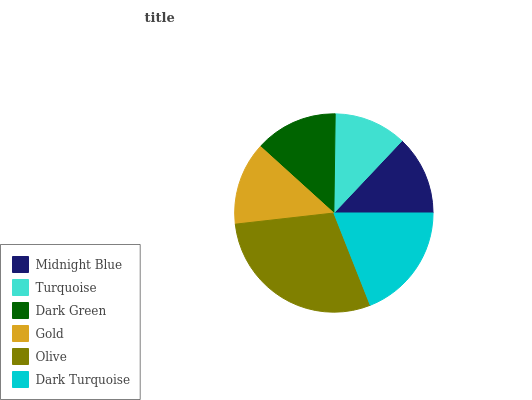Is Turquoise the minimum?
Answer yes or no. Yes. Is Olive the maximum?
Answer yes or no. Yes. Is Dark Green the minimum?
Answer yes or no. No. Is Dark Green the maximum?
Answer yes or no. No. Is Dark Green greater than Turquoise?
Answer yes or no. Yes. Is Turquoise less than Dark Green?
Answer yes or no. Yes. Is Turquoise greater than Dark Green?
Answer yes or no. No. Is Dark Green less than Turquoise?
Answer yes or no. No. Is Gold the high median?
Answer yes or no. Yes. Is Dark Green the low median?
Answer yes or no. Yes. Is Dark Green the high median?
Answer yes or no. No. Is Gold the low median?
Answer yes or no. No. 